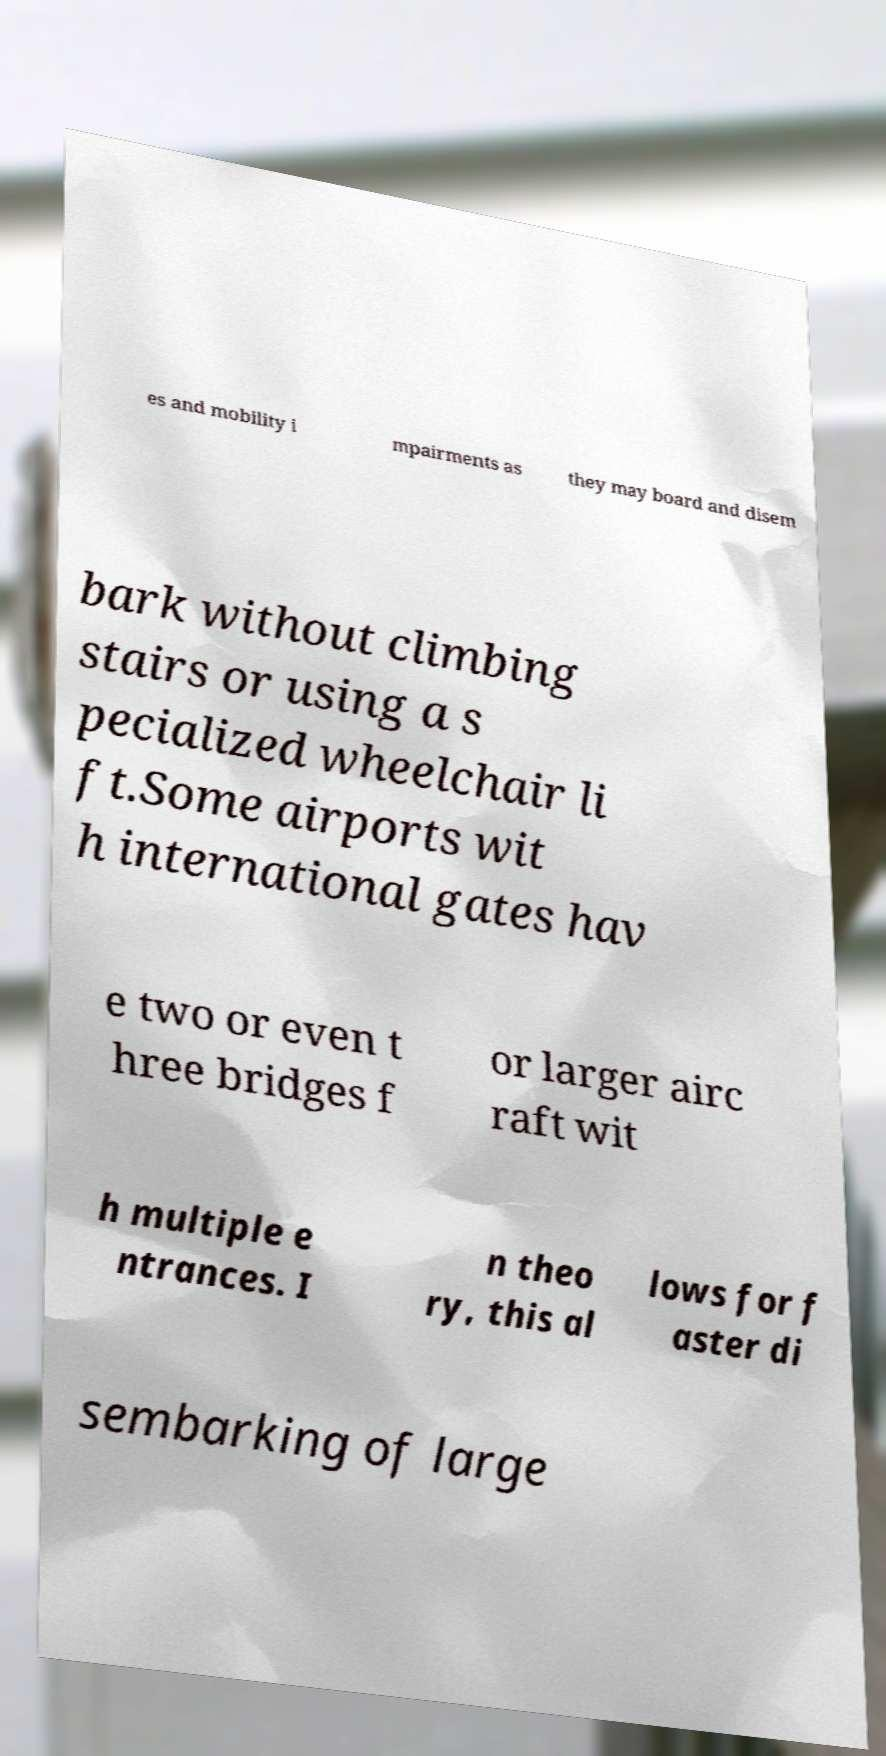Please identify and transcribe the text found in this image. es and mobility i mpairments as they may board and disem bark without climbing stairs or using a s pecialized wheelchair li ft.Some airports wit h international gates hav e two or even t hree bridges f or larger airc raft wit h multiple e ntrances. I n theo ry, this al lows for f aster di sembarking of large 